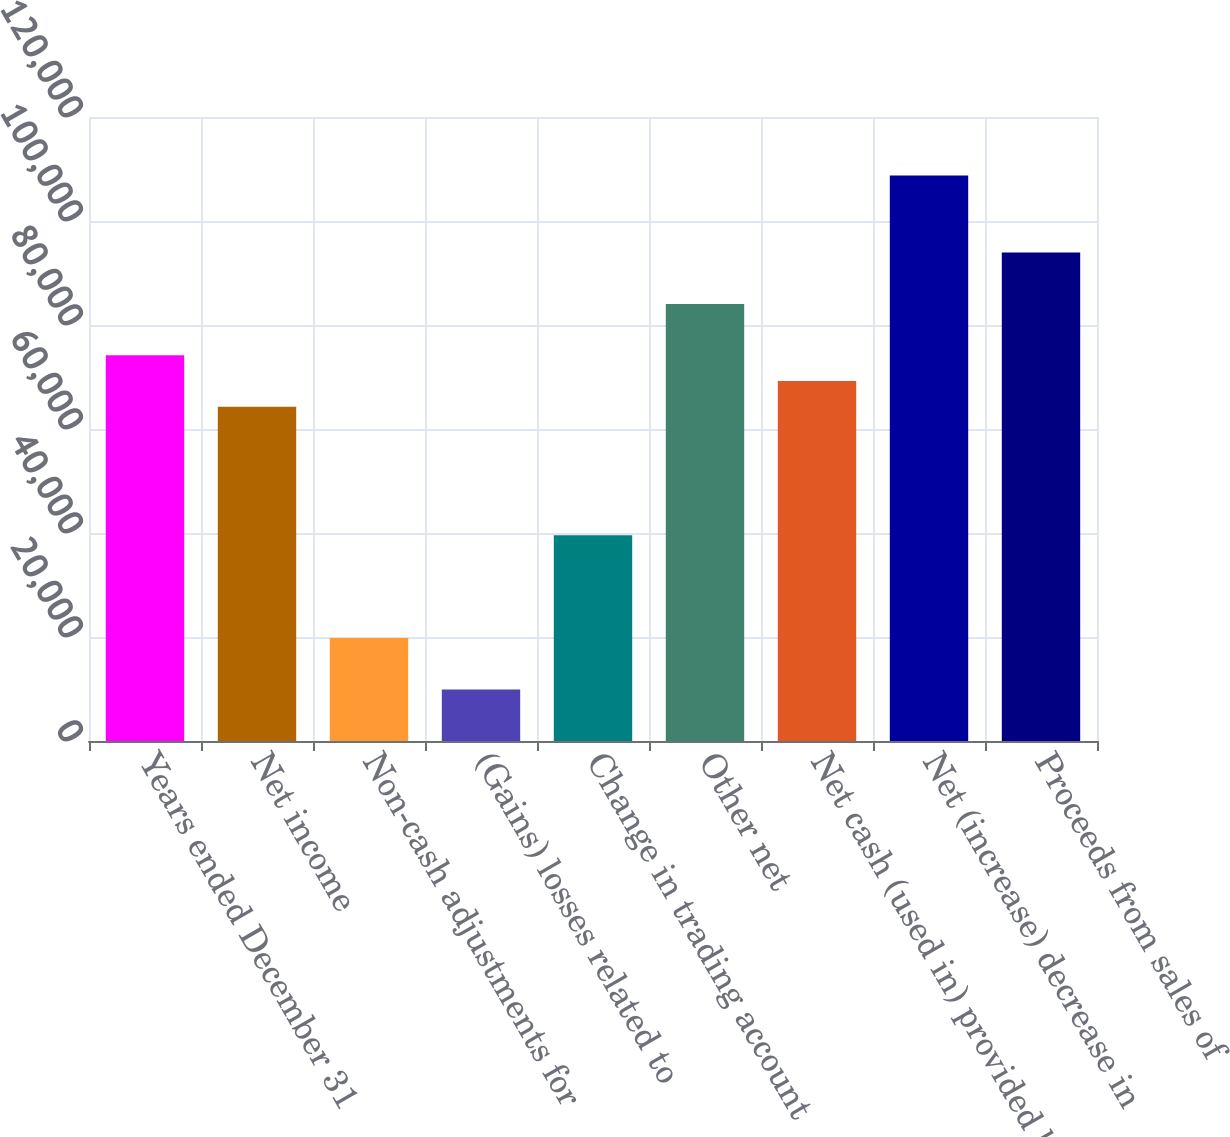Convert chart to OTSL. <chart><loc_0><loc_0><loc_500><loc_500><bar_chart><fcel>Years ended December 31<fcel>Net income<fcel>Non-cash adjustments for<fcel>(Gains) losses related to<fcel>Change in trading account<fcel>Other net<fcel>Net cash (used in) provided by<fcel>Net (increase) decrease in<fcel>Proceeds from sales of<nl><fcel>74171<fcel>64287.4<fcel>19811.2<fcel>9927.6<fcel>39578.4<fcel>84054.6<fcel>69229.2<fcel>108764<fcel>93938.2<nl></chart> 